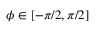<formula> <loc_0><loc_0><loc_500><loc_500>\phi \in [ - \pi / 2 , \pi / 2 ]</formula> 